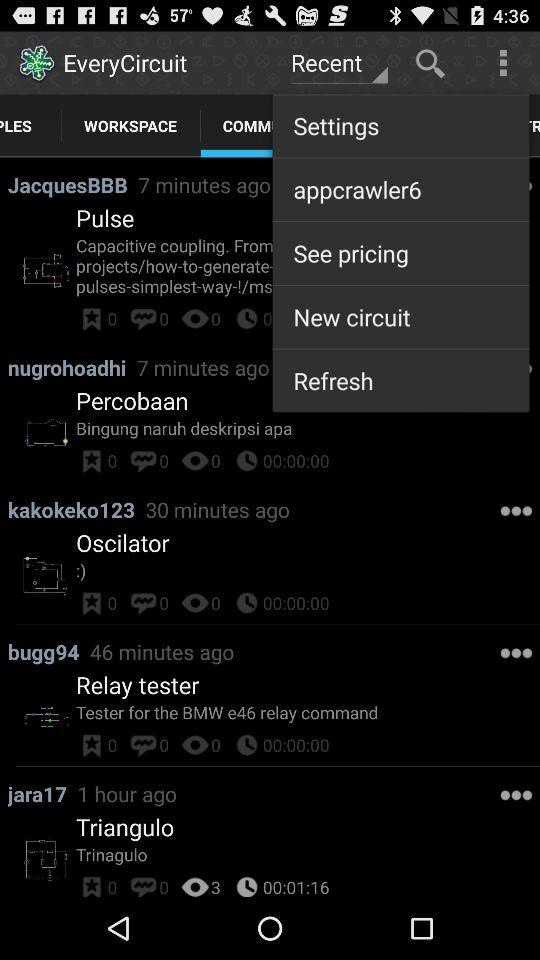How many people have bookmarked "Pulse"? There are 0 people who have bookmarked "Pulse". 